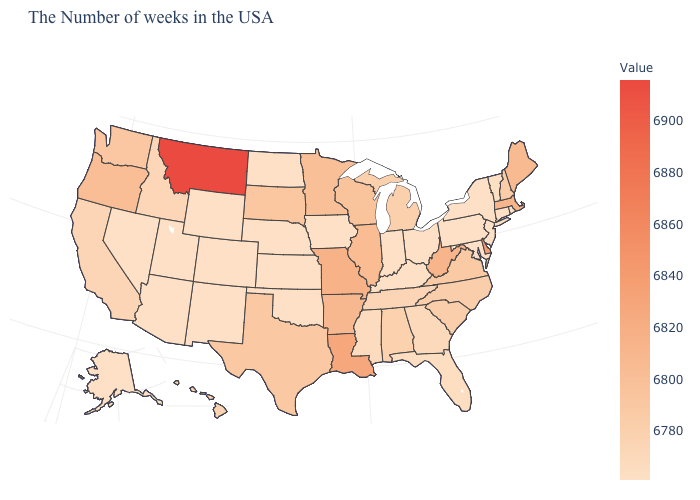Which states have the lowest value in the USA?
Be succinct. Rhode Island, Connecticut, New York, New Jersey, Maryland, Pennsylvania, Ohio, Kentucky, Indiana, Iowa, Kansas, Nebraska, Oklahoma, North Dakota, Wyoming, Colorado, New Mexico, Utah, Arizona, Nevada, Alaska. Does Delaware have the highest value in the South?
Write a very short answer. Yes. Which states have the highest value in the USA?
Answer briefly. Montana. Among the states that border Wyoming , which have the lowest value?
Be succinct. Nebraska, Colorado, Utah. Which states have the lowest value in the West?
Quick response, please. Wyoming, Colorado, New Mexico, Utah, Arizona, Nevada, Alaska. Does Tennessee have the highest value in the USA?
Give a very brief answer. No. Which states have the highest value in the USA?
Write a very short answer. Montana. Does Wisconsin have a higher value than Ohio?
Short answer required. Yes. Does the map have missing data?
Concise answer only. No. 